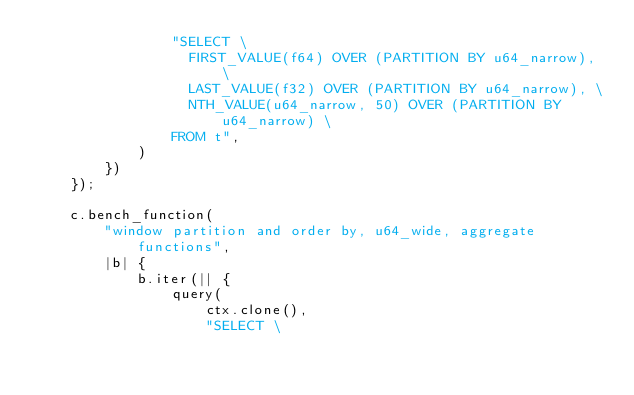<code> <loc_0><loc_0><loc_500><loc_500><_Rust_>                "SELECT \
                  FIRST_VALUE(f64) OVER (PARTITION BY u64_narrow), \
                  LAST_VALUE(f32) OVER (PARTITION BY u64_narrow), \
                  NTH_VALUE(u64_narrow, 50) OVER (PARTITION BY u64_narrow) \
                FROM t",
            )
        })
    });

    c.bench_function(
        "window partition and order by, u64_wide, aggregate functions",
        |b| {
            b.iter(|| {
                query(
                    ctx.clone(),
                    "SELECT \</code> 